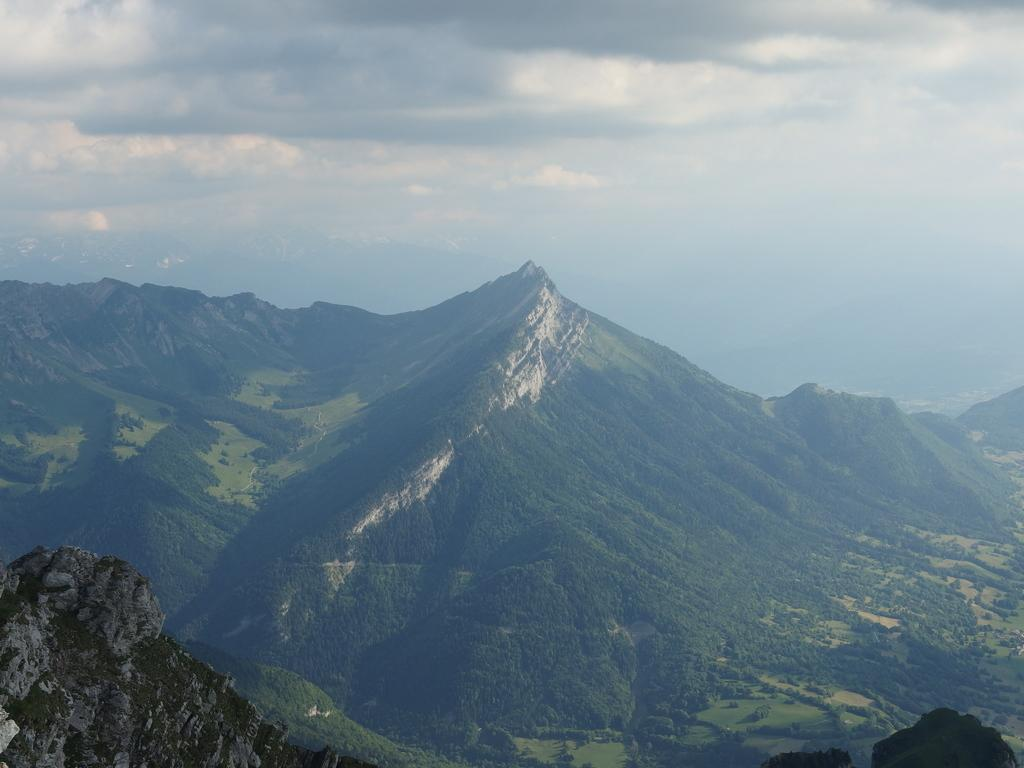What is the main feature in the center of the image? There are mountains in the center of the image. What can be seen at the top of the image? The sky is visible at the top of the image. What is present in the sky? Clouds are present in the sky. What type of wire is being used to rub the clouds in the image? There is no wire or rubbing of clouds present in the image; it simply shows mountains, sky, and clouds. 